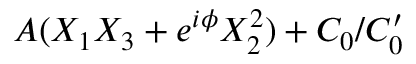Convert formula to latex. <formula><loc_0><loc_0><loc_500><loc_500>A ( X _ { 1 } X _ { 3 } + e ^ { i \phi } X _ { 2 } ^ { 2 } ) + C _ { 0 } / C _ { 0 } ^ { \prime }</formula> 